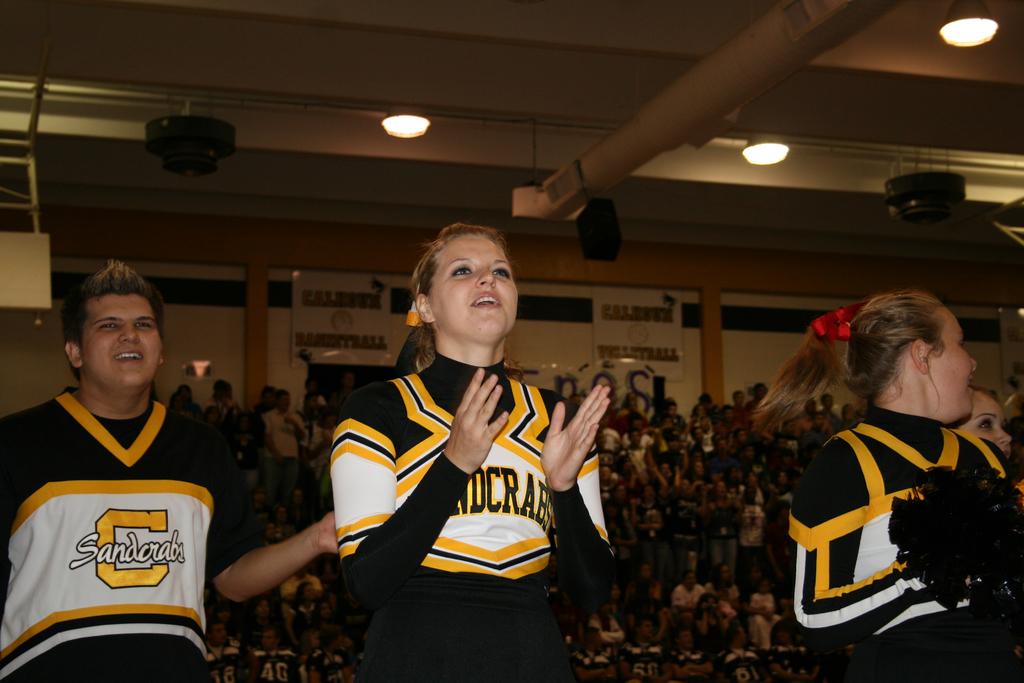What does the male cheerleader's uniform say?
Give a very brief answer. Sandcrabs. 